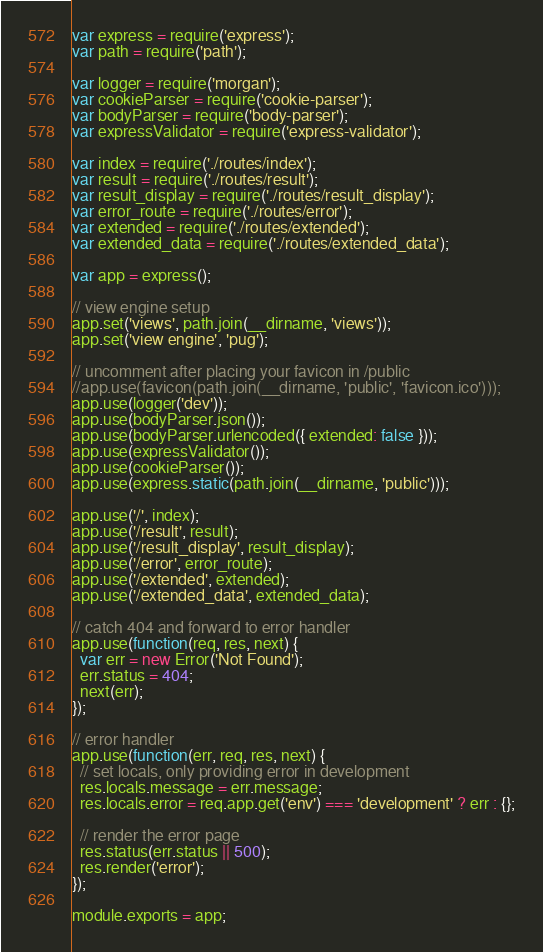<code> <loc_0><loc_0><loc_500><loc_500><_JavaScript_>var express = require('express');
var path = require('path');

var logger = require('morgan');
var cookieParser = require('cookie-parser');
var bodyParser = require('body-parser');
var expressValidator = require('express-validator');

var index = require('./routes/index');
var result = require('./routes/result');
var result_display = require('./routes/result_display');
var error_route = require('./routes/error');
var extended = require('./routes/extended');
var extended_data = require('./routes/extended_data');

var app = express();

// view engine setup
app.set('views', path.join(__dirname, 'views'));
app.set('view engine', 'pug');

// uncomment after placing your favicon in /public
//app.use(favicon(path.join(__dirname, 'public', 'favicon.ico')));
app.use(logger('dev'));
app.use(bodyParser.json());
app.use(bodyParser.urlencoded({ extended: false }));
app.use(expressValidator());
app.use(cookieParser());
app.use(express.static(path.join(__dirname, 'public')));

app.use('/', index);
app.use('/result', result);
app.use('/result_display', result_display);
app.use('/error', error_route);
app.use('/extended', extended);
app.use('/extended_data', extended_data);

// catch 404 and forward to error handler
app.use(function(req, res, next) {
  var err = new Error('Not Found');
  err.status = 404;
  next(err);
});

// error handler
app.use(function(err, req, res, next) {
  // set locals, only providing error in development
  res.locals.message = err.message;
  res.locals.error = req.app.get('env') === 'development' ? err : {};

  // render the error page
  res.status(err.status || 500);
  res.render('error');
});

module.exports = app;
</code> 